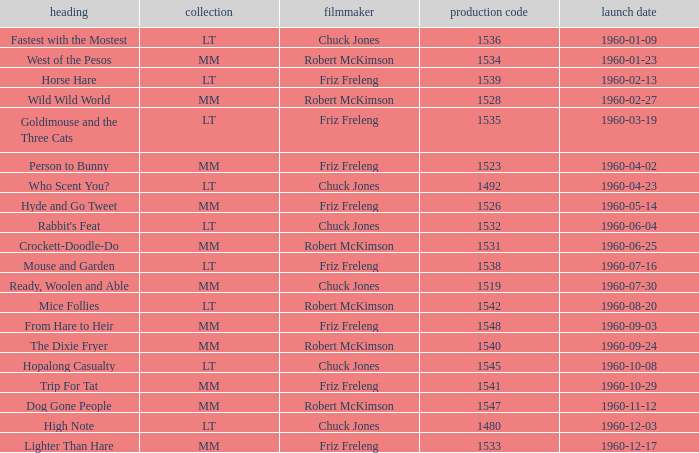What is the production number for the episode directed by Robert McKimson named Mice Follies? 1.0. 